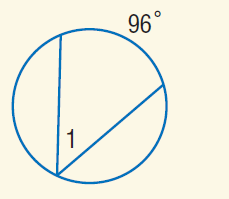Question: Find m \angle 1.
Choices:
A. \pi
B. 48
C. 96
D. 360
Answer with the letter. Answer: B 